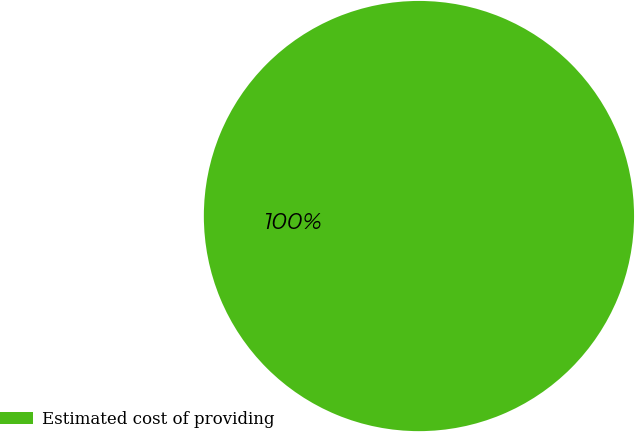<chart> <loc_0><loc_0><loc_500><loc_500><pie_chart><fcel>Estimated cost of providing<nl><fcel>100.0%<nl></chart> 